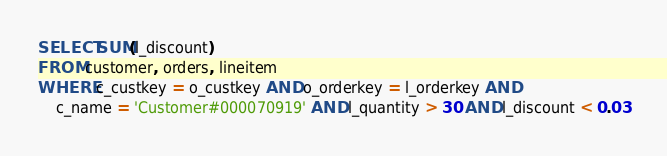Convert code to text. <code><loc_0><loc_0><loc_500><loc_500><_SQL_>SELECT SUM(l_discount) 
FROM customer, orders, lineitem
WHERE c_custkey = o_custkey AND o_orderkey = l_orderkey AND
	c_name = 'Customer#000070919' AND l_quantity > 30 AND l_discount < 0.03

</code> 